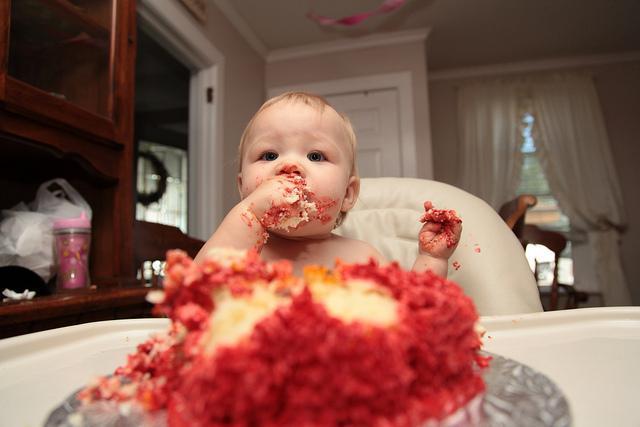Is the caption "The cake is at the left side of the person." a true representation of the image?
Answer yes or no. No. 